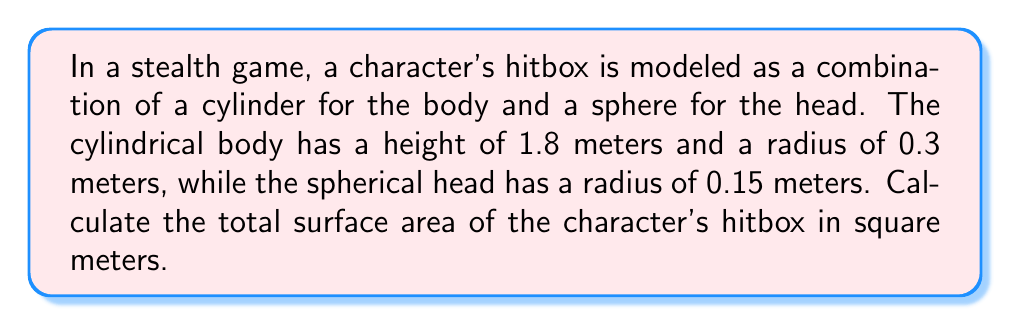Can you answer this question? Let's break this down step-by-step:

1. Calculate the surface area of the cylindrical body:
   The surface area of a cylinder is given by the formula:
   $$A_{cylinder} = 2\pi r h + 2\pi r^2$$
   where $r$ is the radius and $h$ is the height.

   Substituting the values:
   $$A_{cylinder} = 2\pi (0.3)(1.8) + 2\pi (0.3)^2$$
   $$A_{cylinder} = 3.39292 + 0.56548 = 3.9584 \text{ m}^2$$

2. Calculate the surface area of the spherical head:
   The surface area of a sphere is given by the formula:
   $$A_{sphere} = 4\pi r^2$$
   where $r$ is the radius.

   Substituting the value:
   $$A_{sphere} = 4\pi (0.15)^2 = 0.2827 \text{ m}^2$$

3. Sum up the total surface area:
   $$A_{total} = A_{cylinder} + A_{sphere}$$
   $$A_{total} = 3.9584 + 0.2827 = 4.2411 \text{ m}^2$$

[asy]
import three;

size(200);
currentprojection=perspective(6,3,2);

// Draw cylinder
draw(cylinder((0,0,0),0.3,1.8),blue+opacity(0.5));

// Draw sphere
draw(shift(0,0,1.8)*scale3(0.15)*unitsphere,red+opacity(0.5));

// Labels
label("Body", (0.5,0,0.9));
label("Head", (0.2,0,2));
[/asy]
Answer: 4.2411 m² 